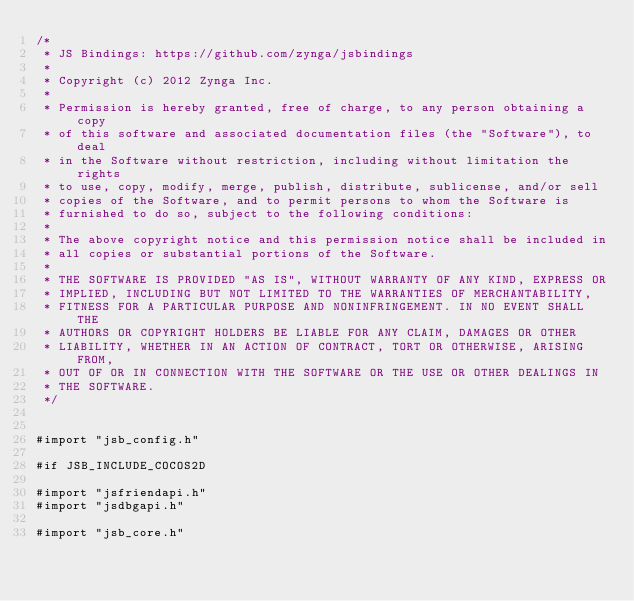<code> <loc_0><loc_0><loc_500><loc_500><_ObjectiveC_>/*
 * JS Bindings: https://github.com/zynga/jsbindings
 *
 * Copyright (c) 2012 Zynga Inc.
 *
 * Permission is hereby granted, free of charge, to any person obtaining a copy
 * of this software and associated documentation files (the "Software"), to deal
 * in the Software without restriction, including without limitation the rights
 * to use, copy, modify, merge, publish, distribute, sublicense, and/or sell
 * copies of the Software, and to permit persons to whom the Software is
 * furnished to do so, subject to the following conditions:
 *
 * The above copyright notice and this permission notice shall be included in
 * all copies or substantial portions of the Software.
 *
 * THE SOFTWARE IS PROVIDED "AS IS", WITHOUT WARRANTY OF ANY KIND, EXPRESS OR
 * IMPLIED, INCLUDING BUT NOT LIMITED TO THE WARRANTIES OF MERCHANTABILITY,
 * FITNESS FOR A PARTICULAR PURPOSE AND NONINFRINGEMENT. IN NO EVENT SHALL THE
 * AUTHORS OR COPYRIGHT HOLDERS BE LIABLE FOR ANY CLAIM, DAMAGES OR OTHER
 * LIABILITY, WHETHER IN AN ACTION OF CONTRACT, TORT OR OTHERWISE, ARISING FROM,
 * OUT OF OR IN CONNECTION WITH THE SOFTWARE OR THE USE OR OTHER DEALINGS IN
 * THE SOFTWARE.
 */


#import "jsb_config.h"

#if JSB_INCLUDE_COCOS2D

#import "jsfriendapi.h"
#import "jsdbgapi.h"

#import "jsb_core.h"</code> 